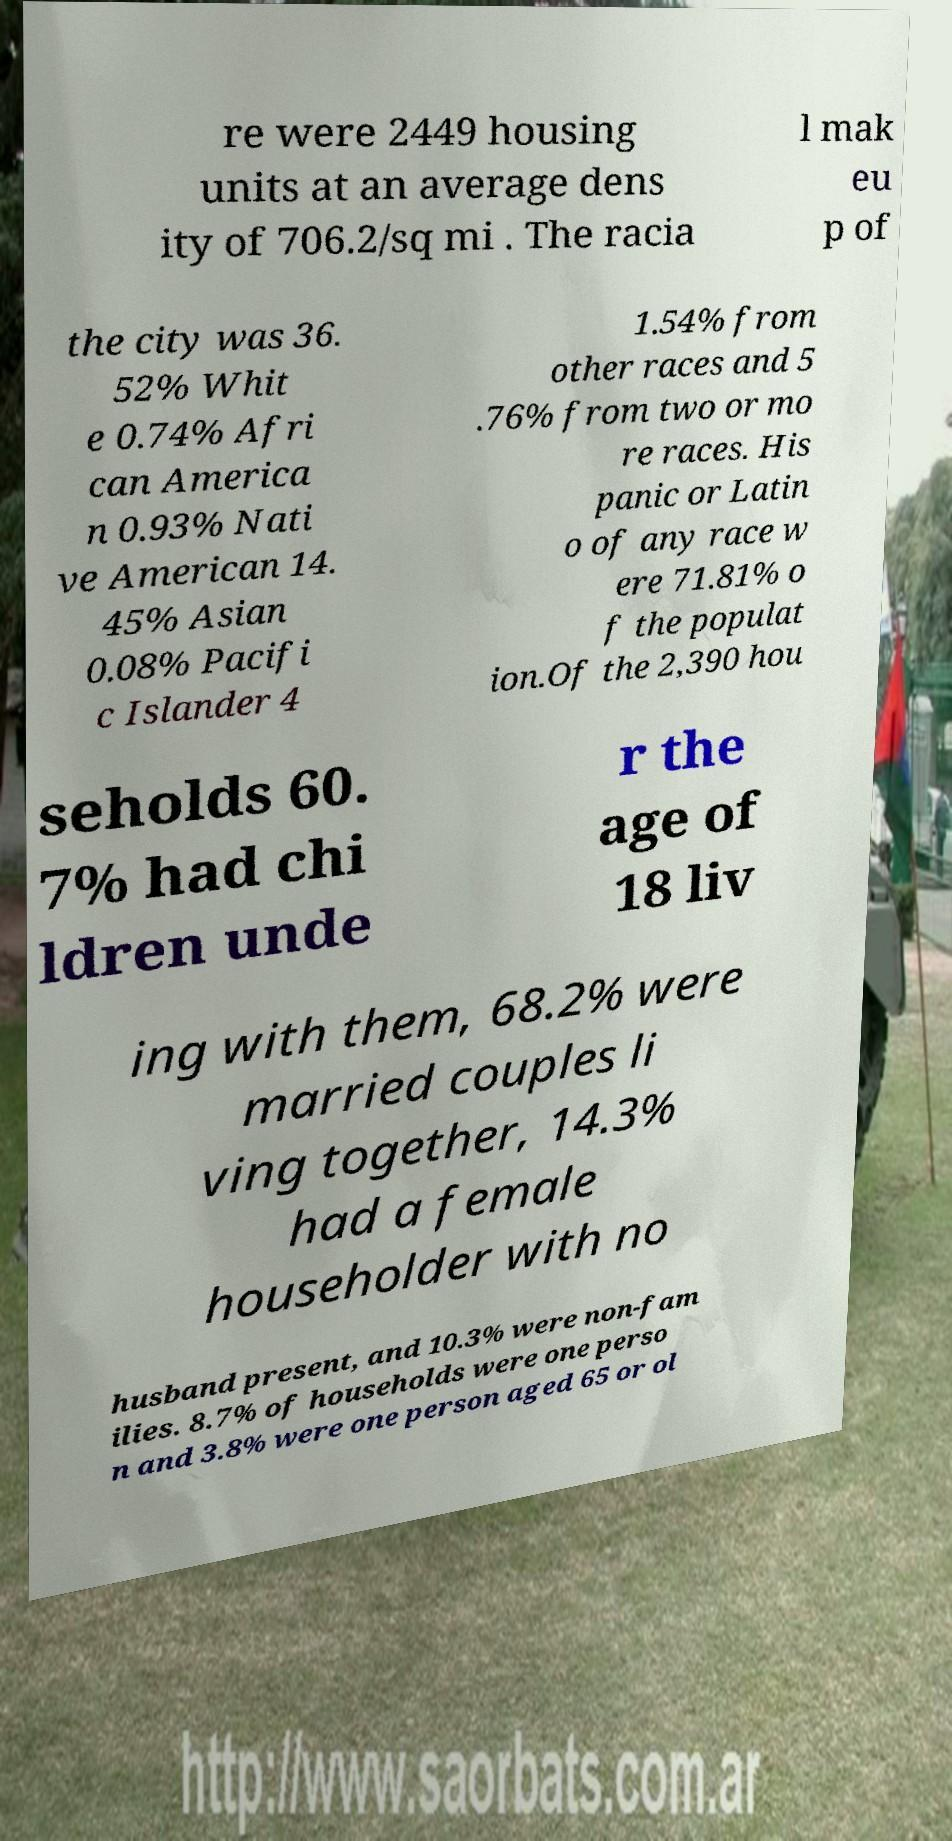What messages or text are displayed in this image? I need them in a readable, typed format. re were 2449 housing units at an average dens ity of 706.2/sq mi . The racia l mak eu p of the city was 36. 52% Whit e 0.74% Afri can America n 0.93% Nati ve American 14. 45% Asian 0.08% Pacifi c Islander 4 1.54% from other races and 5 .76% from two or mo re races. His panic or Latin o of any race w ere 71.81% o f the populat ion.Of the 2,390 hou seholds 60. 7% had chi ldren unde r the age of 18 liv ing with them, 68.2% were married couples li ving together, 14.3% had a female householder with no husband present, and 10.3% were non-fam ilies. 8.7% of households were one perso n and 3.8% were one person aged 65 or ol 